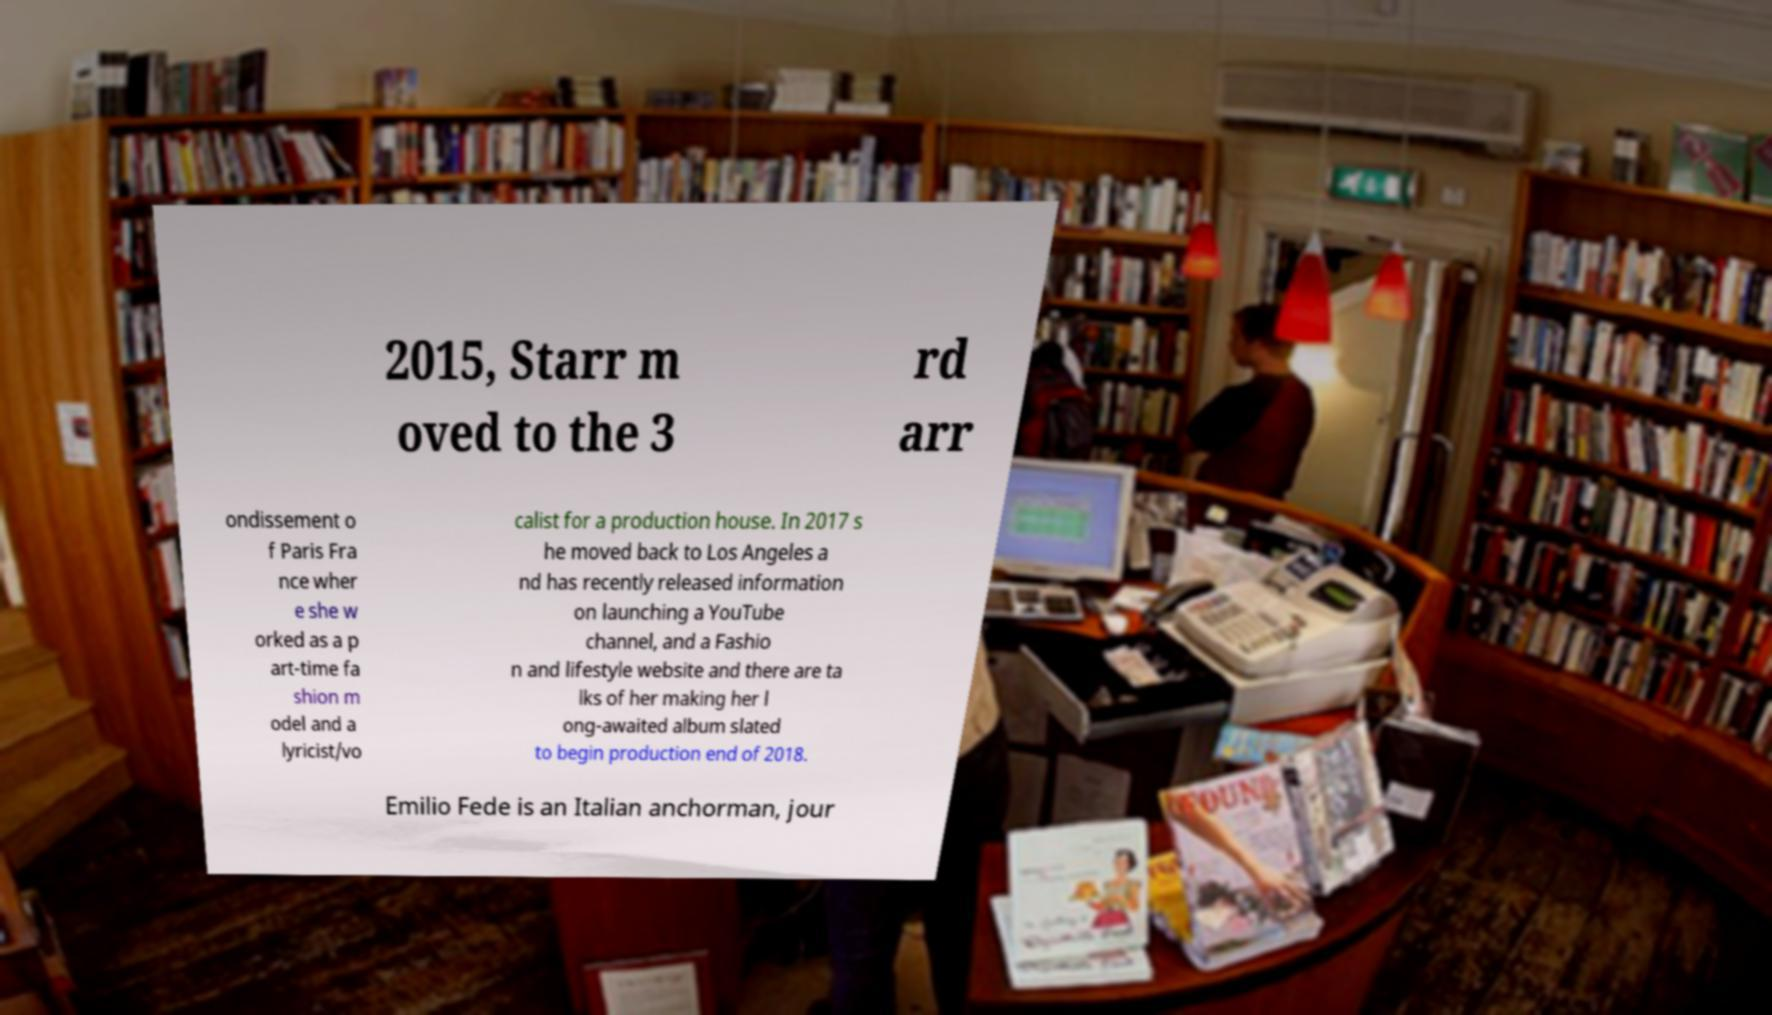Please read and relay the text visible in this image. What does it say? 2015, Starr m oved to the 3 rd arr ondissement o f Paris Fra nce wher e she w orked as a p art-time fa shion m odel and a lyricist/vo calist for a production house. In 2017 s he moved back to Los Angeles a nd has recently released information on launching a YouTube channel, and a Fashio n and lifestyle website and there are ta lks of her making her l ong-awaited album slated to begin production end of 2018. Emilio Fede is an Italian anchorman, jour 